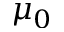Convert formula to latex. <formula><loc_0><loc_0><loc_500><loc_500>\mu _ { 0 }</formula> 